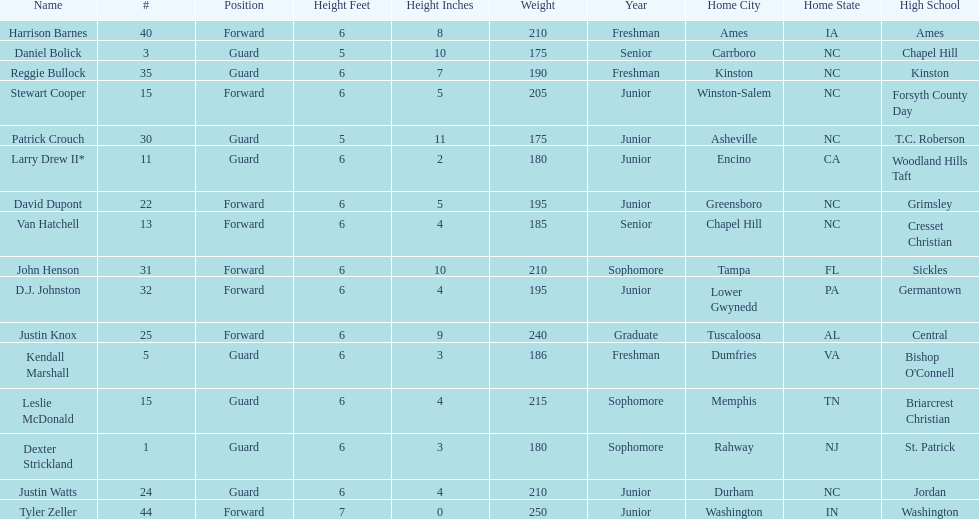How many players are not a junior? 9. 